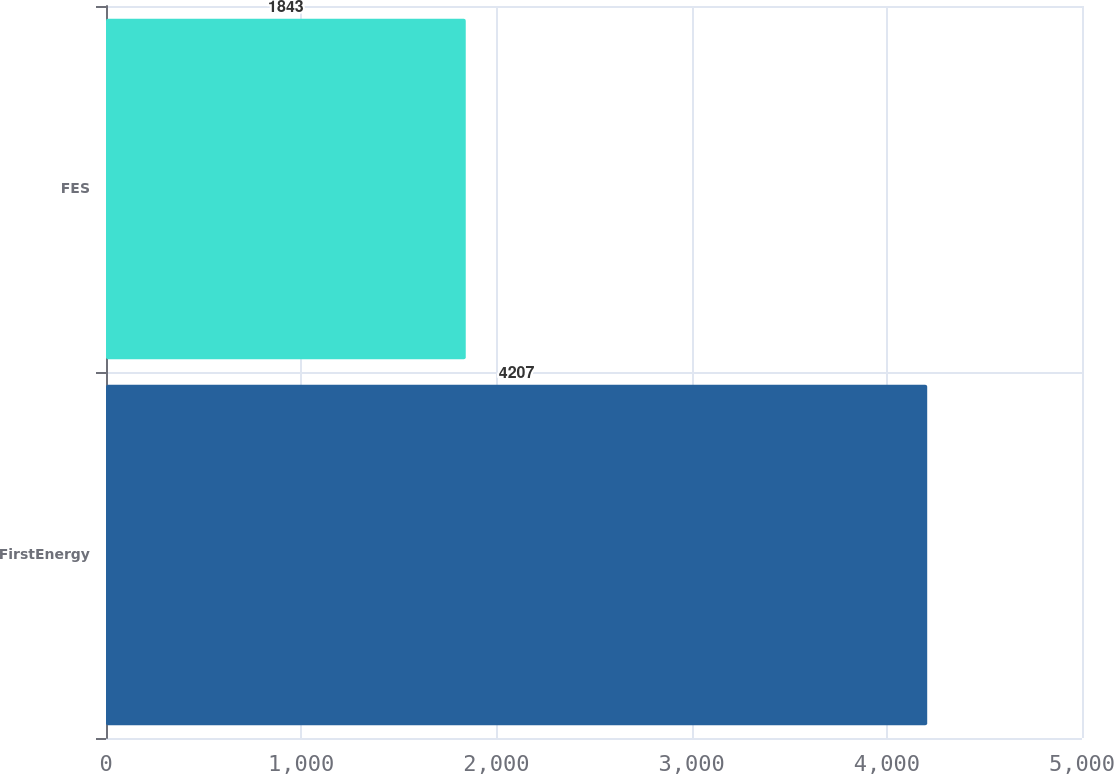<chart> <loc_0><loc_0><loc_500><loc_500><bar_chart><fcel>FirstEnergy<fcel>FES<nl><fcel>4207<fcel>1843<nl></chart> 